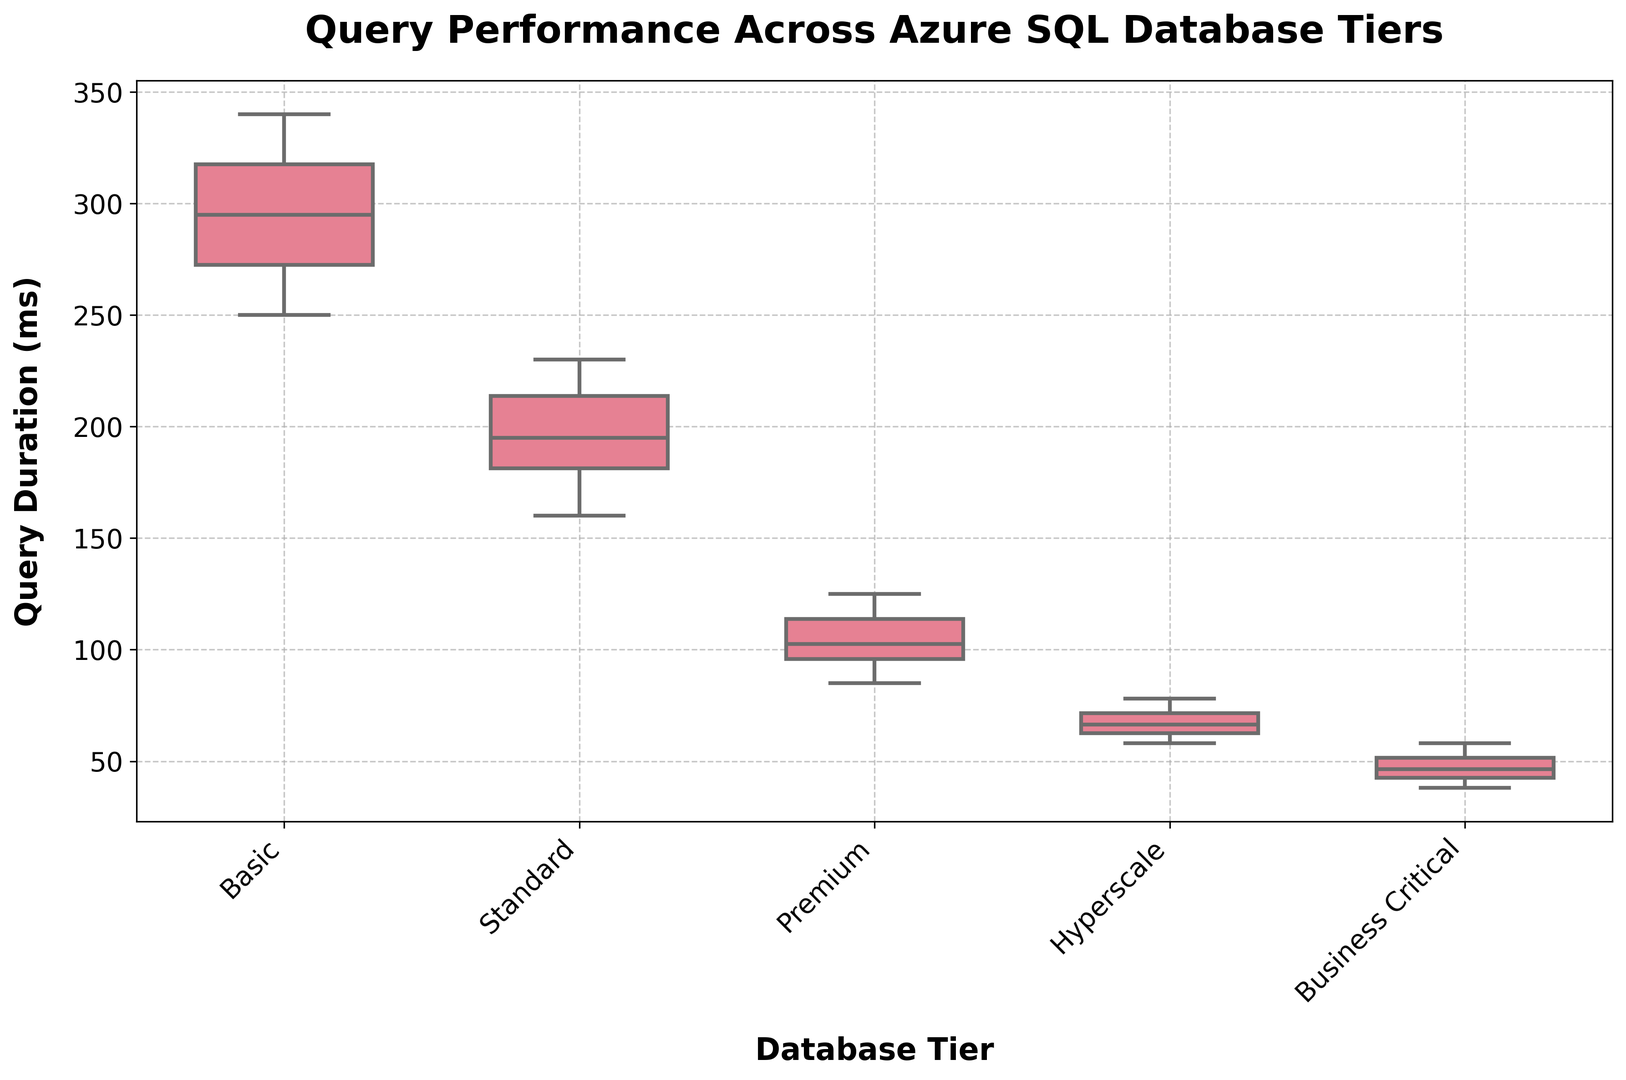What is the median query duration for the Standard tier? The median is the middle value of the query durations when they are sorted in ascending order. For the Standard tier, the sorted query durations are: 160, 170, 180, 185, 190, 200, 210, 215, 220, 230. The median value (middle value) is (190 + 200) / 2 = 195.
Answer: 195 Which database tier has the longest query duration? The box plot allows us to compare the maximum values of each tier. By visual inspection, the Basic tier has the whisker extending to the highest value, indicating the longest query duration.
Answer: Basic How does the query performance of Hyperscale compare to Premium? To compare Hyperscale and Premium, examine the quartiles and median values from the box plots. Hyperscale has lower quartiles and medians than Premium, indicating better performance (shorter query duration) on average.
Answer: Hyperscale is better Which tier has the smallest interquartile range (IQR) for query duration? The IQR is the range between the first (Q1) and third (Q3) quartiles. By visual inspection, Business Critical has the shortest box length, indicating the smallest IQR.
Answer: Business Critical What is the range of the query durations for the Premium tier? The range is the difference between the maximum and minimum values. For Premium, the maximum value is 125 ms and the minimum value is 85 ms, so the range is 125 - 85 = 40 ms.
Answer: 40 ms Between which two tiers is the difference in the median query duration the largest? To determine this, compare the medians visually. Business Critical and Basic show the largest difference. The median of Business Critical is considerably lower than that of Basic.
Answer: Business Critical and Basic Is there any overlap in the interquartile range (IQR) of the Premium and Standard tiers? By examining the boxes of the Premium and Standard tiers, we see that there is no overlap between the IQRs of these two tiers.
Answer: No What is the upper whisker value for the Basic tier? The upper whisker represents the maximum value within 1.5 times the IQR from the upper quartile. For the Basic tier, it extends to 340 ms.
Answer: 340 ms How does the spread (variability) in query durations for the Basic tier compare to Business Critical? By comparing the box plot widths and whiskers' lengths, Basic tier shows much wider spread and longer whiskers compared to Business Critical, indicating greater variability.
Answer: Basic has greater variability 